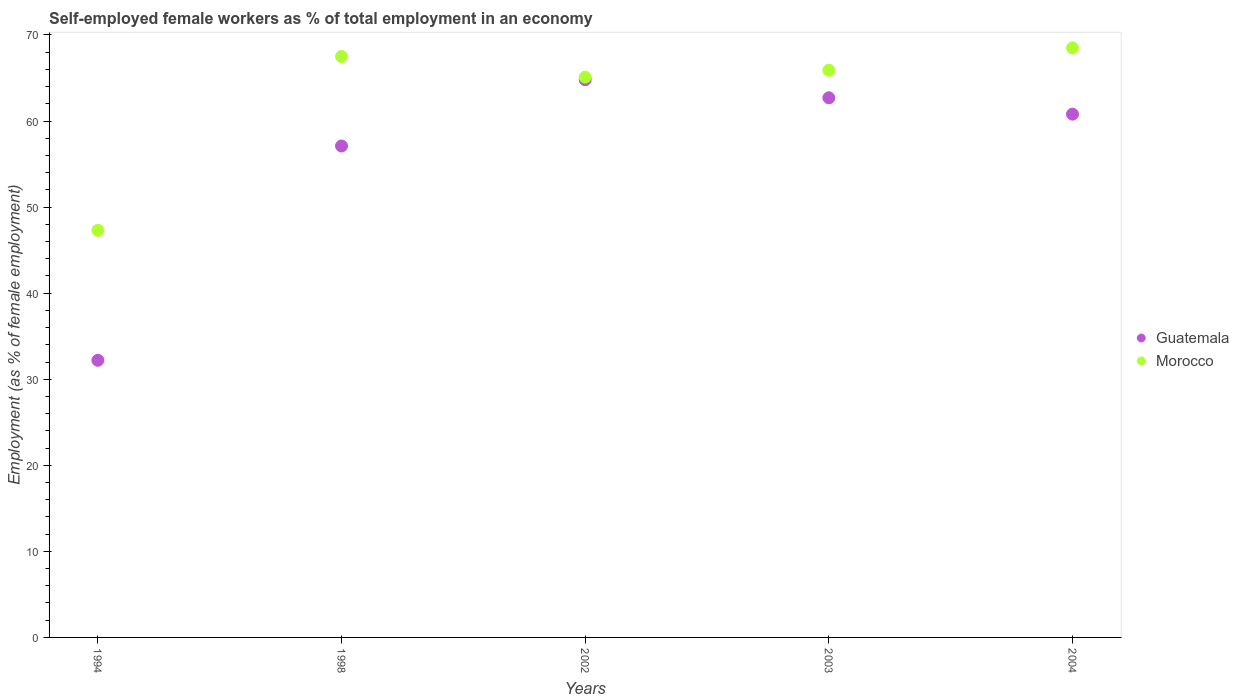What is the percentage of self-employed female workers in Guatemala in 2002?
Your response must be concise. 64.8. Across all years, what is the maximum percentage of self-employed female workers in Guatemala?
Your response must be concise. 64.8. Across all years, what is the minimum percentage of self-employed female workers in Morocco?
Keep it short and to the point. 47.3. In which year was the percentage of self-employed female workers in Morocco maximum?
Your response must be concise. 2004. What is the total percentage of self-employed female workers in Morocco in the graph?
Your answer should be very brief. 314.3. What is the difference between the percentage of self-employed female workers in Guatemala in 1994 and that in 2003?
Your answer should be very brief. -30.5. What is the difference between the percentage of self-employed female workers in Guatemala in 1998 and the percentage of self-employed female workers in Morocco in 1994?
Provide a succinct answer. 9.8. What is the average percentage of self-employed female workers in Morocco per year?
Provide a succinct answer. 62.86. In the year 2004, what is the difference between the percentage of self-employed female workers in Morocco and percentage of self-employed female workers in Guatemala?
Provide a succinct answer. 7.7. What is the ratio of the percentage of self-employed female workers in Guatemala in 2003 to that in 2004?
Give a very brief answer. 1.03. Is the difference between the percentage of self-employed female workers in Morocco in 2003 and 2004 greater than the difference between the percentage of self-employed female workers in Guatemala in 2003 and 2004?
Provide a succinct answer. No. What is the difference between the highest and the second highest percentage of self-employed female workers in Guatemala?
Provide a short and direct response. 2.1. What is the difference between the highest and the lowest percentage of self-employed female workers in Guatemala?
Provide a short and direct response. 32.6. In how many years, is the percentage of self-employed female workers in Guatemala greater than the average percentage of self-employed female workers in Guatemala taken over all years?
Keep it short and to the point. 4. Is the sum of the percentage of self-employed female workers in Guatemala in 2002 and 2003 greater than the maximum percentage of self-employed female workers in Morocco across all years?
Offer a very short reply. Yes. Does the percentage of self-employed female workers in Morocco monotonically increase over the years?
Your response must be concise. No. Is the percentage of self-employed female workers in Morocco strictly greater than the percentage of self-employed female workers in Guatemala over the years?
Provide a succinct answer. Yes. Is the percentage of self-employed female workers in Guatemala strictly less than the percentage of self-employed female workers in Morocco over the years?
Your answer should be very brief. Yes. How many years are there in the graph?
Provide a short and direct response. 5. Are the values on the major ticks of Y-axis written in scientific E-notation?
Your answer should be very brief. No. Does the graph contain any zero values?
Your answer should be compact. No. Does the graph contain grids?
Provide a short and direct response. No. How are the legend labels stacked?
Offer a very short reply. Vertical. What is the title of the graph?
Keep it short and to the point. Self-employed female workers as % of total employment in an economy. What is the label or title of the X-axis?
Ensure brevity in your answer.  Years. What is the label or title of the Y-axis?
Keep it short and to the point. Employment (as % of female employment). What is the Employment (as % of female employment) in Guatemala in 1994?
Keep it short and to the point. 32.2. What is the Employment (as % of female employment) in Morocco in 1994?
Your response must be concise. 47.3. What is the Employment (as % of female employment) of Guatemala in 1998?
Offer a very short reply. 57.1. What is the Employment (as % of female employment) in Morocco in 1998?
Your answer should be very brief. 67.5. What is the Employment (as % of female employment) in Guatemala in 2002?
Your response must be concise. 64.8. What is the Employment (as % of female employment) of Morocco in 2002?
Give a very brief answer. 65.1. What is the Employment (as % of female employment) of Guatemala in 2003?
Offer a terse response. 62.7. What is the Employment (as % of female employment) of Morocco in 2003?
Your answer should be very brief. 65.9. What is the Employment (as % of female employment) of Guatemala in 2004?
Offer a very short reply. 60.8. What is the Employment (as % of female employment) in Morocco in 2004?
Provide a succinct answer. 68.5. Across all years, what is the maximum Employment (as % of female employment) in Guatemala?
Provide a succinct answer. 64.8. Across all years, what is the maximum Employment (as % of female employment) in Morocco?
Give a very brief answer. 68.5. Across all years, what is the minimum Employment (as % of female employment) of Guatemala?
Offer a very short reply. 32.2. Across all years, what is the minimum Employment (as % of female employment) in Morocco?
Ensure brevity in your answer.  47.3. What is the total Employment (as % of female employment) of Guatemala in the graph?
Provide a succinct answer. 277.6. What is the total Employment (as % of female employment) of Morocco in the graph?
Give a very brief answer. 314.3. What is the difference between the Employment (as % of female employment) of Guatemala in 1994 and that in 1998?
Ensure brevity in your answer.  -24.9. What is the difference between the Employment (as % of female employment) in Morocco in 1994 and that in 1998?
Give a very brief answer. -20.2. What is the difference between the Employment (as % of female employment) of Guatemala in 1994 and that in 2002?
Your response must be concise. -32.6. What is the difference between the Employment (as % of female employment) of Morocco in 1994 and that in 2002?
Your answer should be compact. -17.8. What is the difference between the Employment (as % of female employment) in Guatemala in 1994 and that in 2003?
Offer a very short reply. -30.5. What is the difference between the Employment (as % of female employment) in Morocco in 1994 and that in 2003?
Your response must be concise. -18.6. What is the difference between the Employment (as % of female employment) of Guatemala in 1994 and that in 2004?
Your answer should be compact. -28.6. What is the difference between the Employment (as % of female employment) of Morocco in 1994 and that in 2004?
Your answer should be very brief. -21.2. What is the difference between the Employment (as % of female employment) of Guatemala in 1998 and that in 2002?
Your answer should be very brief. -7.7. What is the difference between the Employment (as % of female employment) in Morocco in 1998 and that in 2002?
Provide a short and direct response. 2.4. What is the difference between the Employment (as % of female employment) in Morocco in 1998 and that in 2003?
Your answer should be very brief. 1.6. What is the difference between the Employment (as % of female employment) in Guatemala in 1998 and that in 2004?
Offer a very short reply. -3.7. What is the difference between the Employment (as % of female employment) of Morocco in 1998 and that in 2004?
Make the answer very short. -1. What is the difference between the Employment (as % of female employment) in Guatemala in 2002 and that in 2003?
Your answer should be very brief. 2.1. What is the difference between the Employment (as % of female employment) in Morocco in 2002 and that in 2004?
Provide a short and direct response. -3.4. What is the difference between the Employment (as % of female employment) of Guatemala in 2003 and that in 2004?
Make the answer very short. 1.9. What is the difference between the Employment (as % of female employment) of Morocco in 2003 and that in 2004?
Ensure brevity in your answer.  -2.6. What is the difference between the Employment (as % of female employment) in Guatemala in 1994 and the Employment (as % of female employment) in Morocco in 1998?
Provide a short and direct response. -35.3. What is the difference between the Employment (as % of female employment) of Guatemala in 1994 and the Employment (as % of female employment) of Morocco in 2002?
Your answer should be very brief. -32.9. What is the difference between the Employment (as % of female employment) of Guatemala in 1994 and the Employment (as % of female employment) of Morocco in 2003?
Your answer should be compact. -33.7. What is the difference between the Employment (as % of female employment) of Guatemala in 1994 and the Employment (as % of female employment) of Morocco in 2004?
Ensure brevity in your answer.  -36.3. What is the difference between the Employment (as % of female employment) in Guatemala in 2003 and the Employment (as % of female employment) in Morocco in 2004?
Your response must be concise. -5.8. What is the average Employment (as % of female employment) of Guatemala per year?
Provide a short and direct response. 55.52. What is the average Employment (as % of female employment) in Morocco per year?
Offer a very short reply. 62.86. In the year 1994, what is the difference between the Employment (as % of female employment) of Guatemala and Employment (as % of female employment) of Morocco?
Provide a short and direct response. -15.1. In the year 1998, what is the difference between the Employment (as % of female employment) in Guatemala and Employment (as % of female employment) in Morocco?
Give a very brief answer. -10.4. In the year 2003, what is the difference between the Employment (as % of female employment) in Guatemala and Employment (as % of female employment) in Morocco?
Keep it short and to the point. -3.2. In the year 2004, what is the difference between the Employment (as % of female employment) of Guatemala and Employment (as % of female employment) of Morocco?
Your answer should be very brief. -7.7. What is the ratio of the Employment (as % of female employment) in Guatemala in 1994 to that in 1998?
Provide a succinct answer. 0.56. What is the ratio of the Employment (as % of female employment) in Morocco in 1994 to that in 1998?
Offer a very short reply. 0.7. What is the ratio of the Employment (as % of female employment) of Guatemala in 1994 to that in 2002?
Give a very brief answer. 0.5. What is the ratio of the Employment (as % of female employment) of Morocco in 1994 to that in 2002?
Provide a short and direct response. 0.73. What is the ratio of the Employment (as % of female employment) in Guatemala in 1994 to that in 2003?
Provide a short and direct response. 0.51. What is the ratio of the Employment (as % of female employment) of Morocco in 1994 to that in 2003?
Your answer should be very brief. 0.72. What is the ratio of the Employment (as % of female employment) of Guatemala in 1994 to that in 2004?
Provide a short and direct response. 0.53. What is the ratio of the Employment (as % of female employment) of Morocco in 1994 to that in 2004?
Provide a succinct answer. 0.69. What is the ratio of the Employment (as % of female employment) of Guatemala in 1998 to that in 2002?
Your response must be concise. 0.88. What is the ratio of the Employment (as % of female employment) of Morocco in 1998 to that in 2002?
Keep it short and to the point. 1.04. What is the ratio of the Employment (as % of female employment) in Guatemala in 1998 to that in 2003?
Give a very brief answer. 0.91. What is the ratio of the Employment (as % of female employment) in Morocco in 1998 to that in 2003?
Your answer should be very brief. 1.02. What is the ratio of the Employment (as % of female employment) of Guatemala in 1998 to that in 2004?
Give a very brief answer. 0.94. What is the ratio of the Employment (as % of female employment) in Morocco in 1998 to that in 2004?
Your answer should be compact. 0.99. What is the ratio of the Employment (as % of female employment) of Guatemala in 2002 to that in 2003?
Keep it short and to the point. 1.03. What is the ratio of the Employment (as % of female employment) of Morocco in 2002 to that in 2003?
Provide a succinct answer. 0.99. What is the ratio of the Employment (as % of female employment) of Guatemala in 2002 to that in 2004?
Offer a terse response. 1.07. What is the ratio of the Employment (as % of female employment) in Morocco in 2002 to that in 2004?
Your response must be concise. 0.95. What is the ratio of the Employment (as % of female employment) of Guatemala in 2003 to that in 2004?
Offer a very short reply. 1.03. What is the ratio of the Employment (as % of female employment) in Morocco in 2003 to that in 2004?
Your response must be concise. 0.96. What is the difference between the highest and the lowest Employment (as % of female employment) of Guatemala?
Give a very brief answer. 32.6. What is the difference between the highest and the lowest Employment (as % of female employment) of Morocco?
Your answer should be very brief. 21.2. 